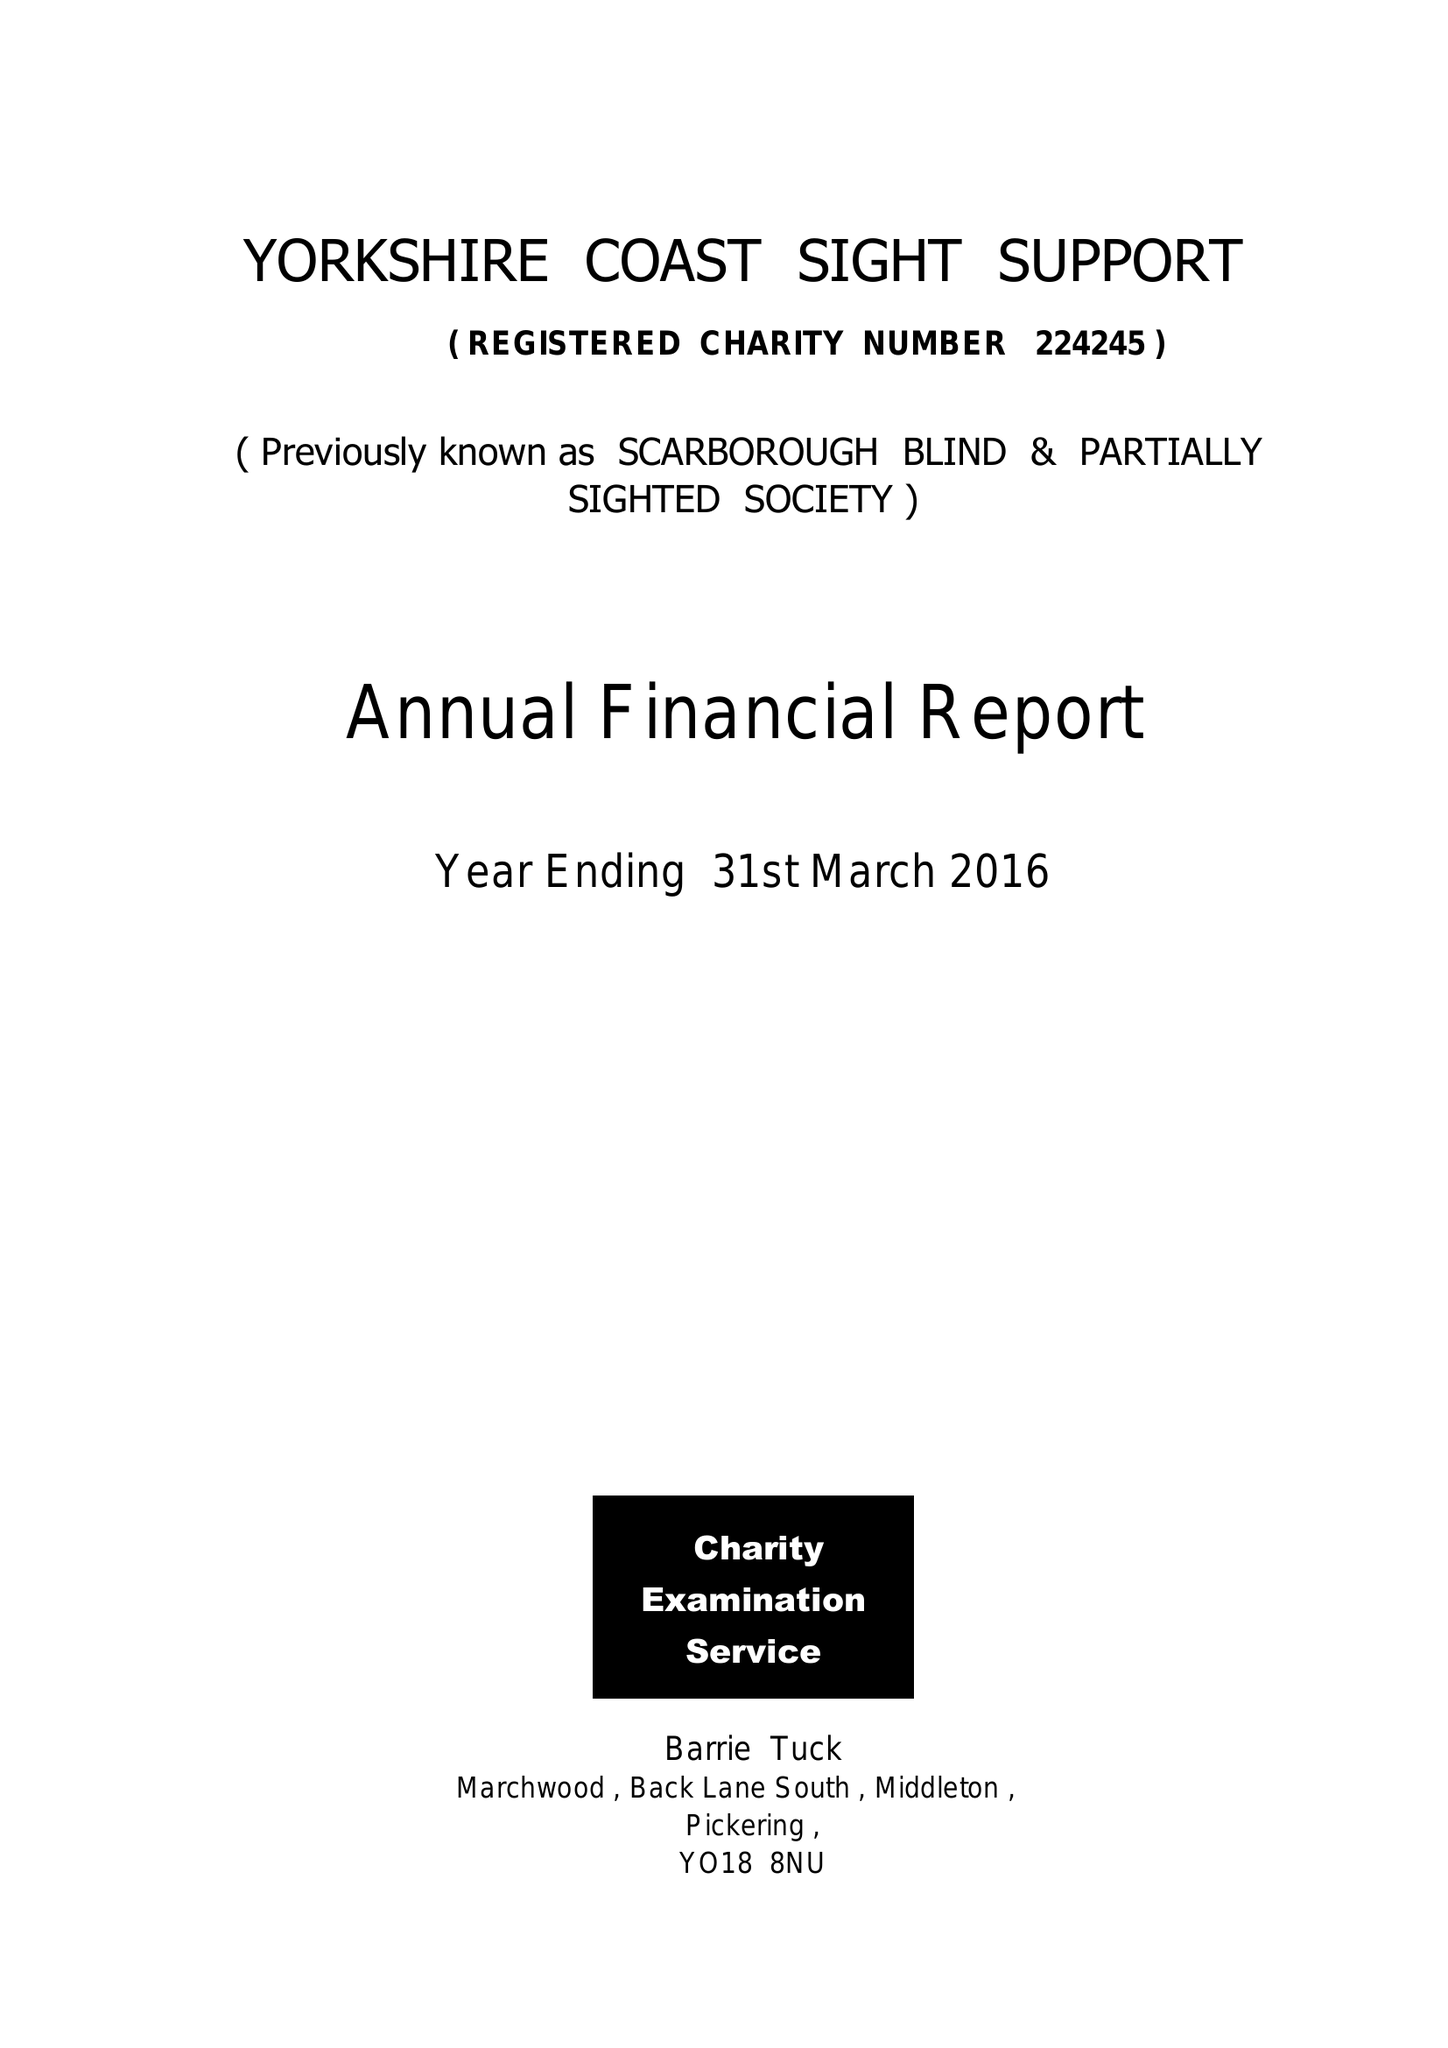What is the value for the charity_number?
Answer the question using a single word or phrase. 224245 